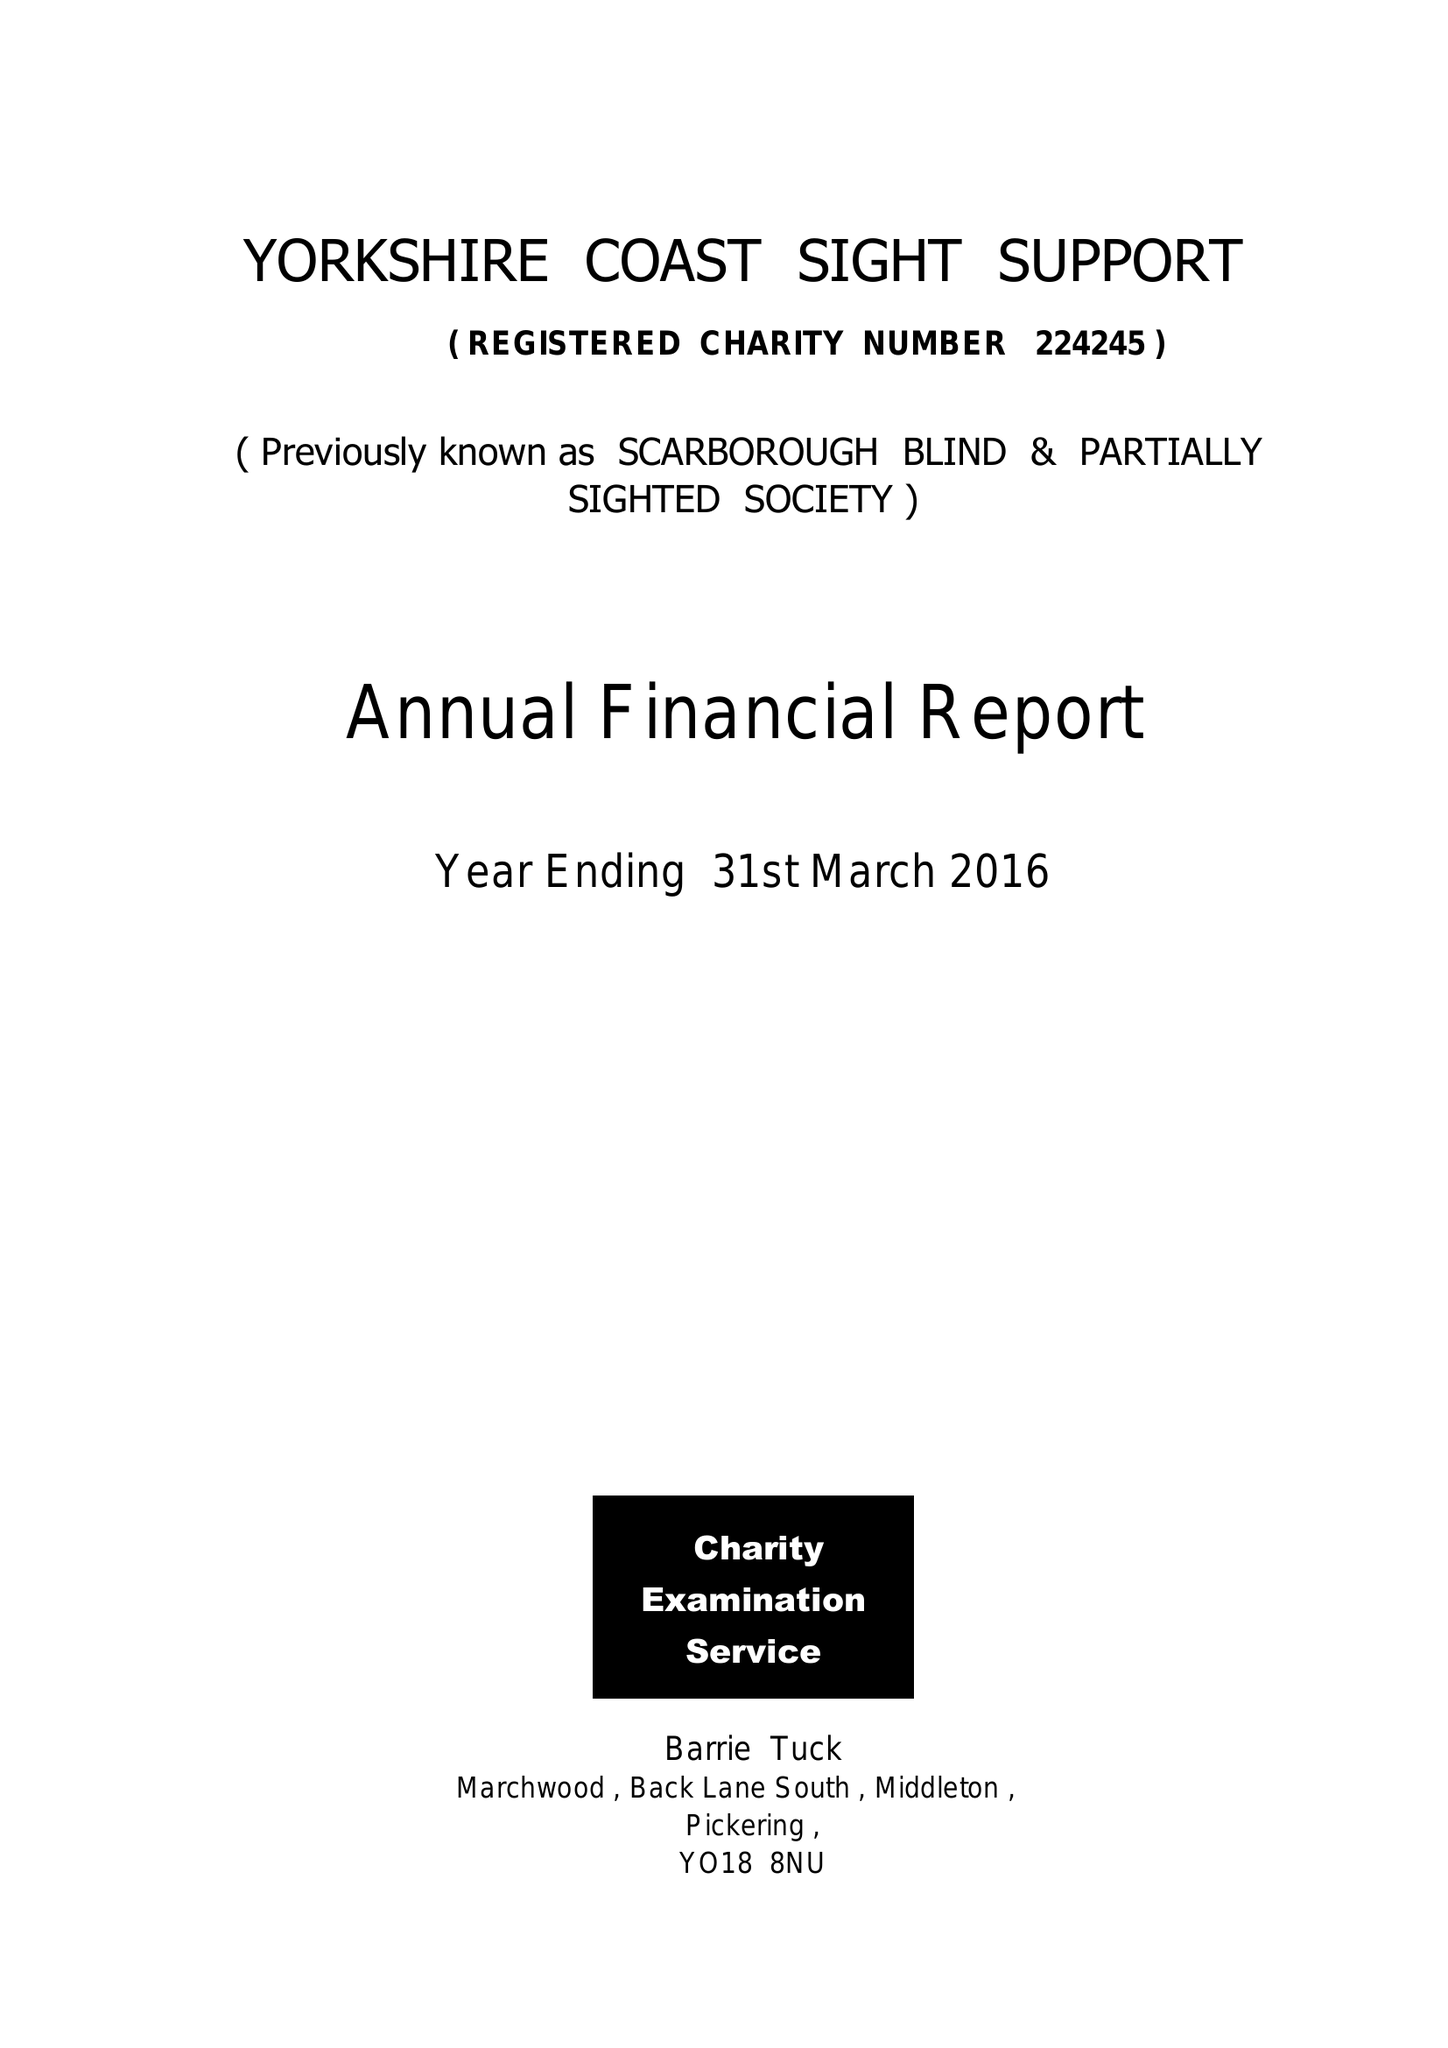What is the value for the charity_number?
Answer the question using a single word or phrase. 224245 